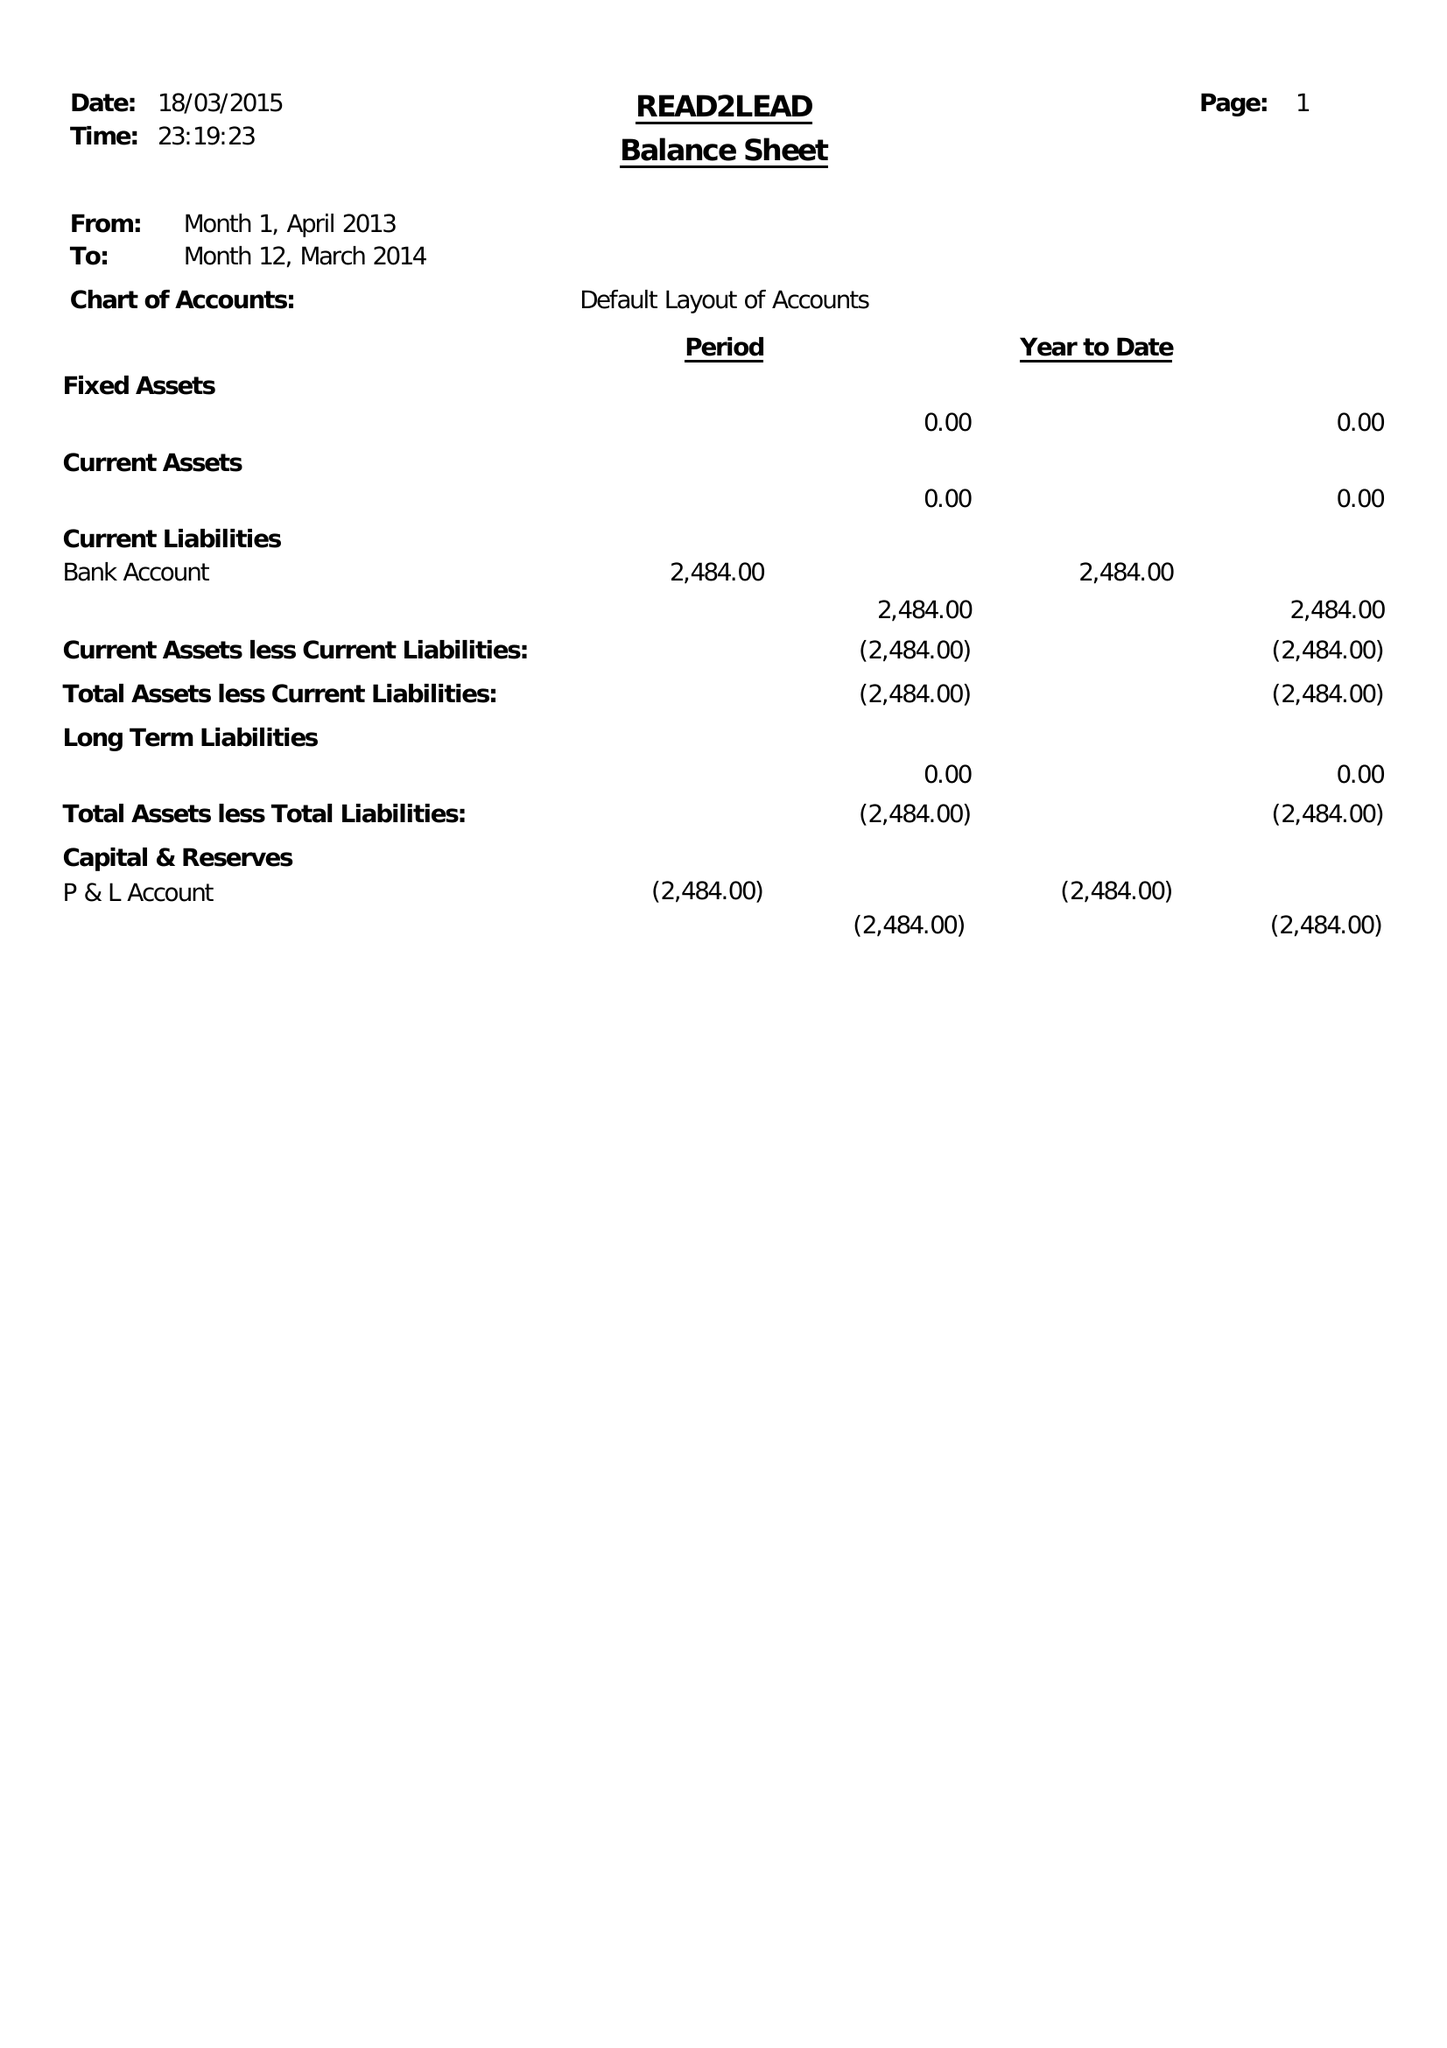What is the value for the address__post_town?
Answer the question using a single word or phrase. BIRMINGHAM 